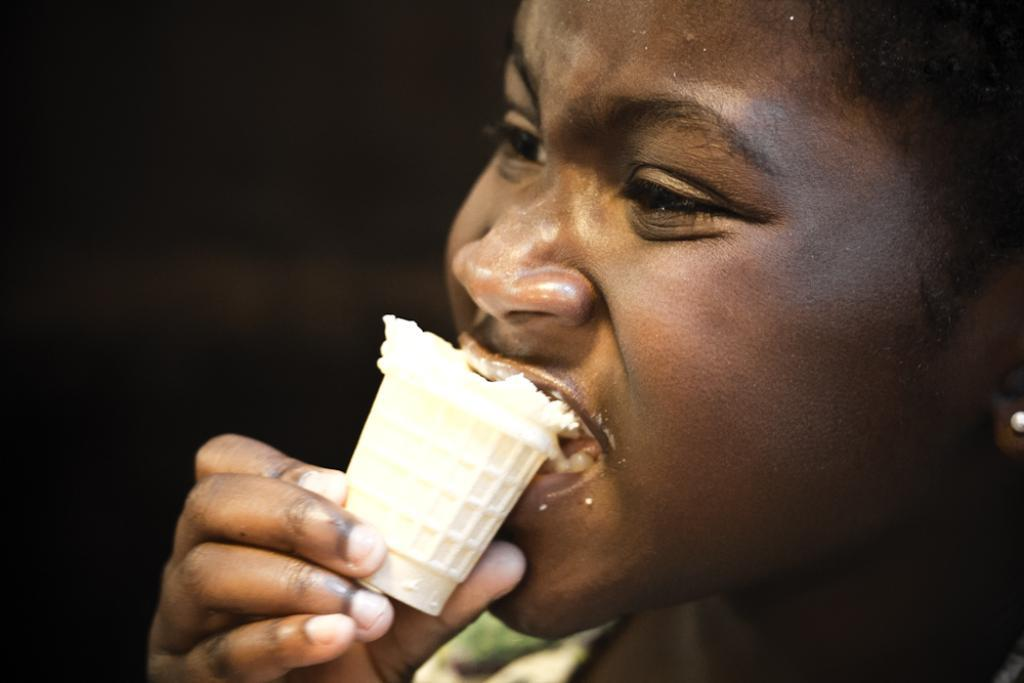What is the main subject of the image? There is a person in the image. What is the person doing in the image? The person is eating a cone. What grade is the person in the image? There is no indication of the person's grade in the image. What type of grass is visible in the image? There is no grass visible in the image. 